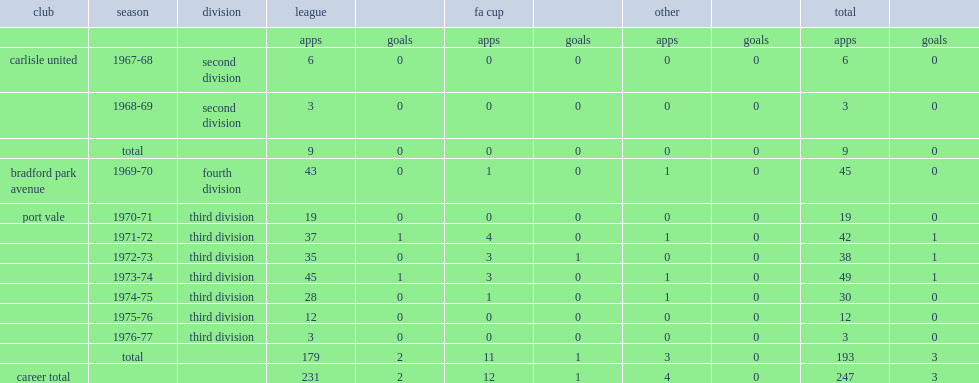Which division did john brodie join bradford park avenue in 1969-70? Fourth division. I'm looking to parse the entire table for insights. Could you assist me with that? {'header': ['club', 'season', 'division', 'league', '', 'fa cup', '', 'other', '', 'total', ''], 'rows': [['', '', '', 'apps', 'goals', 'apps', 'goals', 'apps', 'goals', 'apps', 'goals'], ['carlisle united', '1967-68', 'second division', '6', '0', '0', '0', '0', '0', '6', '0'], ['', '1968-69', 'second division', '3', '0', '0', '0', '0', '0', '3', '0'], ['', 'total', '', '9', '0', '0', '0', '0', '0', '9', '0'], ['bradford park avenue', '1969-70', 'fourth division', '43', '0', '1', '0', '1', '0', '45', '0'], ['port vale', '1970-71', 'third division', '19', '0', '0', '0', '0', '0', '19', '0'], ['', '1971-72', 'third division', '37', '1', '4', '0', '1', '0', '42', '1'], ['', '1972-73', 'third division', '35', '0', '3', '1', '0', '0', '38', '1'], ['', '1973-74', 'third division', '45', '1', '3', '0', '1', '0', '49', '1'], ['', '1974-75', 'third division', '28', '0', '1', '0', '1', '0', '30', '0'], ['', '1975-76', 'third division', '12', '0', '0', '0', '0', '0', '12', '0'], ['', '1976-77', 'third division', '3', '0', '0', '0', '0', '0', '3', '0'], ['', 'total', '', '179', '2', '11', '1', '3', '0', '193', '3'], ['career total', '', '', '231', '2', '12', '1', '4', '0', '247', '3']]} 